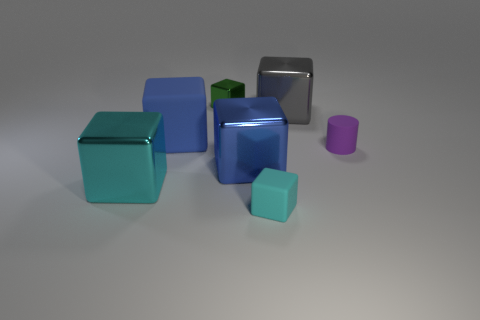Are there more purple cylinders than large yellow cubes?
Offer a very short reply. Yes. What material is the other tiny cyan thing that is the same shape as the cyan shiny object?
Keep it short and to the point. Rubber. Does the tiny purple cylinder have the same material as the tiny cyan cube?
Provide a short and direct response. Yes. Are there more cyan metal objects on the left side of the gray thing than gray balls?
Provide a succinct answer. Yes. What is the cyan object behind the tiny cyan object left of the tiny object that is on the right side of the large gray metal block made of?
Offer a very short reply. Metal. What number of things are either large metallic things or cubes that are in front of the large cyan shiny object?
Ensure brevity in your answer.  4. Do the thing on the left side of the big blue matte block and the small matte cube have the same color?
Provide a succinct answer. Yes. Are there more blue blocks that are right of the big blue matte object than blue blocks on the right side of the tiny matte cylinder?
Your response must be concise. Yes. Is there anything else that is the same color as the cylinder?
Provide a short and direct response. No. What number of objects are tiny cyan matte cubes or metallic things?
Keep it short and to the point. 5. 